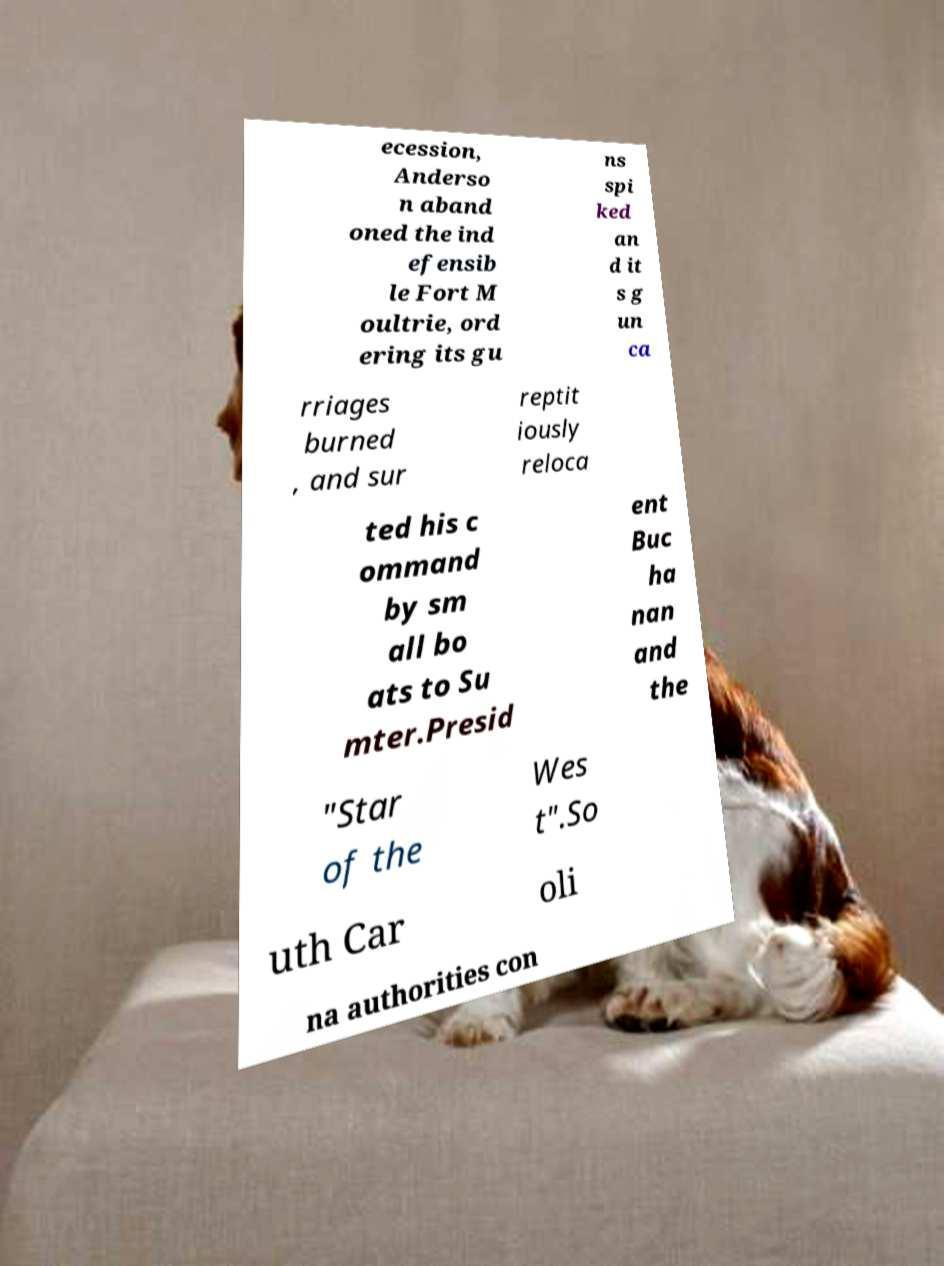Can you accurately transcribe the text from the provided image for me? ecession, Anderso n aband oned the ind efensib le Fort M oultrie, ord ering its gu ns spi ked an d it s g un ca rriages burned , and sur reptit iously reloca ted his c ommand by sm all bo ats to Su mter.Presid ent Buc ha nan and the "Star of the Wes t".So uth Car oli na authorities con 